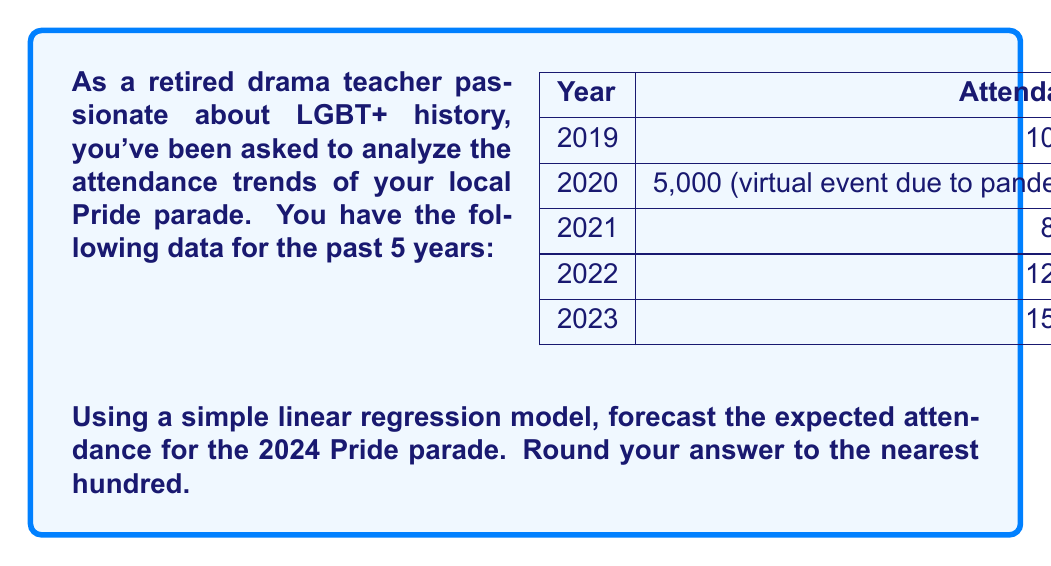Can you answer this question? To forecast the attendance for 2024 using a simple linear regression model, we'll follow these steps:

1. Assign x-values to each year, with 2019 as x = 1, 2020 as x = 2, and so on.

2. Calculate the means of x and y:
   $\bar{x} = \frac{1 + 2 + 3 + 4 + 5}{5} = 3$
   $\bar{y} = \frac{10000 + 5000 + 8000 + 12000 + 15000}{5} = 10000$

3. Calculate the slope (b) using the formula:
   $$b = \frac{\sum(x_i - \bar{x})(y_i - \bar{y})}{\sum(x_i - \bar{x})^2}$$

   $\sum(x_i - \bar{x})(y_i - \bar{y}) = (-2)(-3000) + (-1)(-5000) + (0)(-2000) + (1)(2000) + (2)(5000) = 20000$
   $\sum(x_i - \bar{x})^2 = (-2)^2 + (-1)^2 + 0^2 + 1^2 + 2^2 = 10$

   $b = \frac{20000}{10} = 2000$

4. Calculate the y-intercept (a) using the formula:
   $a = \bar{y} - b\bar{x} = 10000 - 2000(3) = 4000$

5. The linear regression equation is:
   $y = 2000x + 4000$

6. For 2024, x = 6 (as it's the 6th year in our sequence)

7. Forecast the attendance:
   $y = 2000(6) + 4000 = 16000$

Therefore, the forecasted attendance for the 2024 Pride parade is 16,000.
Answer: 16,000 